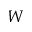Convert formula to latex. <formula><loc_0><loc_0><loc_500><loc_500>W</formula> 